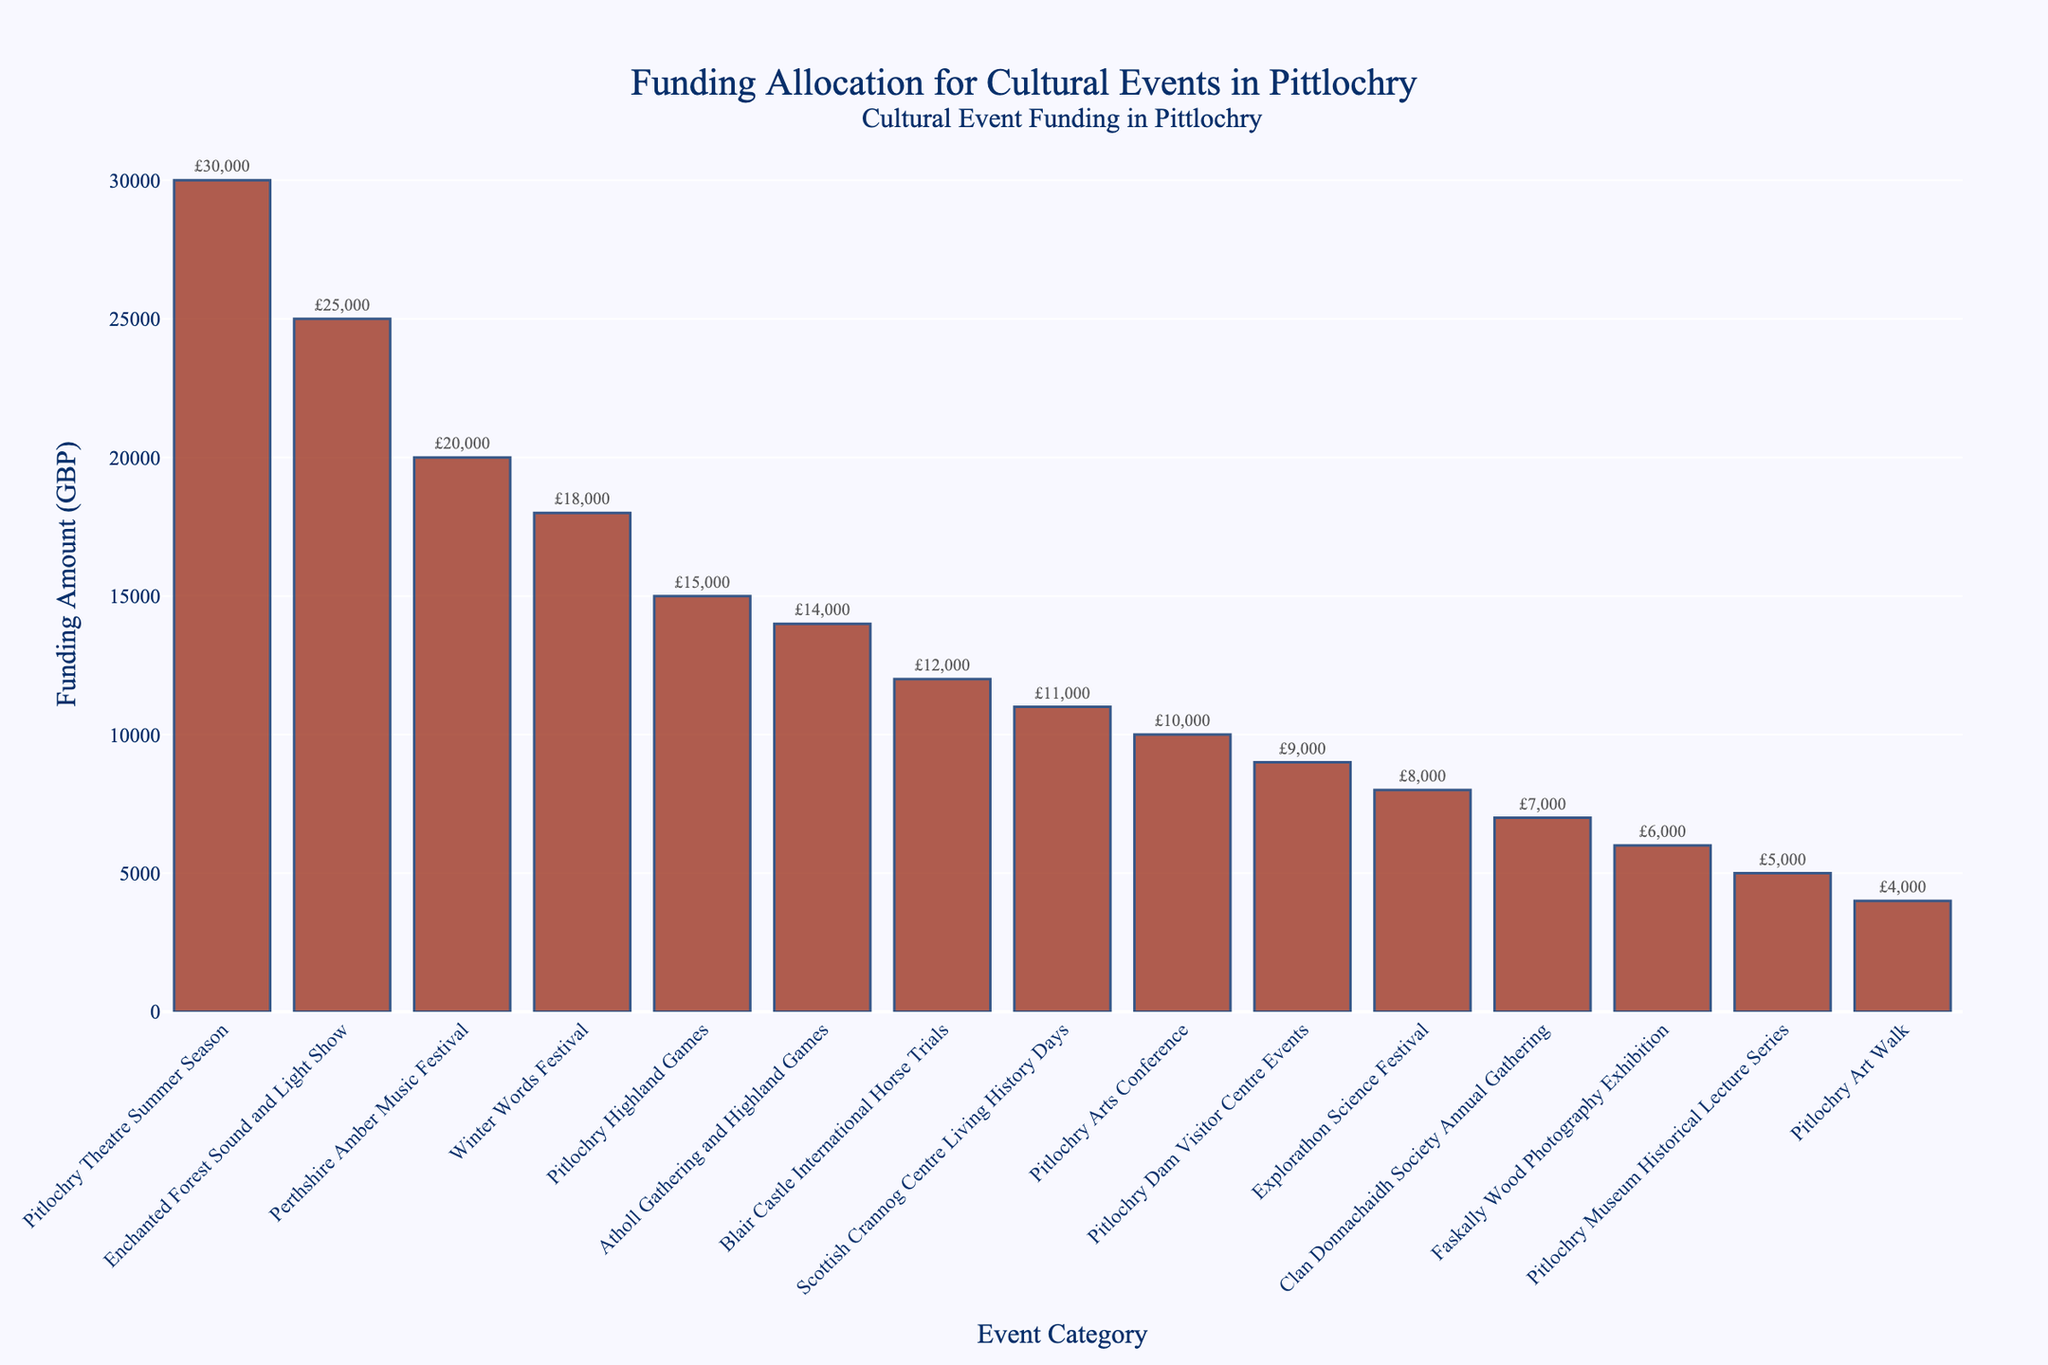Which event category received the highest amount of funding? The highest bar corresponds to the "Pitlochry Theatre Summer Season," which received the highest funding amount.
Answer: Pitlochry Theatre Summer Season How much more funding did the Enchanted Forest Sound and Light Show receive compared to the Pitlochry Highland Games? The funding for the Enchanted Forest Sound and Light Show is £25,000, while the funding for the Pitlochry Highland Games is £15,000. The difference between the two is £25,000 - £15,000 = £10,000.
Answer: £10,000 What is the total funding allocated for historical events (Pitlochry Highland Games, Atholl Gathering and Highland Games, Blair Castle International Horse Trials, Clan Donnachaidh Society Annual Gathering)? Adding the funding for historical events: £15,000 (Pitlochry Highland Games) + £14,000 (Atholl Gathering and Highland Games) + £12,000 (Blair Castle International Horse Trials) + £7,000 (Clan Donnachaidh Society Annual Gathering) = £48,000.
Answer: £48,000 Which event category received the least amount of funding, and what was the amount? The shortest bar corresponds to the "Pitlochry Art Walk," which received the least funding amount.
Answer: Pitlochry Art Walk; £4,000 Are there more events that received funding over £10,000 or under £10,000? Count the bars representing funding over £10,000 (7 events: Pitlochry Highland Games, Enchanted Forest Sound and Light Show, Pitlochry Theatre Summer Season, Blair Castle International Horse Trials, Atholl Gathering and Highland Games, Winter Words Festival, Perthshire Amber Music Festival) and under £10,000 (8 events: Explorathon Science Festival, Clan Donnachaidh Society Annual Gathering, Pitlochry Dam Visitor Centre Events, Scottish Crannog Centre Living History Days, Pitlochry Arts Conference, Pitlochry Museum Historical Lecture Series, Faskally Wood Photography Exhibition, Pitlochry Art Walk).
Answer: Under £10,000 What is the combined funding for the "Winter Words Festival" and "Perthshire Amber Music Festival"? Add the funding for the Winter Words Festival (£18,000) and the Perthshire Amber Music Festival (£20,000): £18,000 + £20,000 = £38,000.
Answer: £38,000 Which category of event received more funding: festivals or exhibitions (considering Faskally Wood Photography Exhibition and any other relevant exhibitions)? Festivals have higher funding: Pitlochry Theatre Summer Season (£30,000), Enchanted Forest (£25,000), Perthshire Amber (£20,000), Winter Words (£18,000), and others, outnumbering the Faskally Wood Photography Exhibition (£6,000) and related exhibitions.
Answer: Festivals What is the average funding amount for all listed cultural events? Sum the total funding and divide by the number of events: (£15,000 + £25,000 + £30,000 + £8,000 + £12,000 + £10,000 + £14,000 + £6,000 + £5,000 + £18,000 + £20,000 + £7,000 + £9,000 + £11,000 + £4,000) / 15 = £194,000 / 15 = £12,933.33.
Answer: £12,933.33 Which event categories received an equal amount of funding and what is that amount? The categories "Atholl Gathering and Highland Games" and "Blair Castle International Horse Trials" received equal funding of £12,000 each.
Answer: Atholl Gathering and Highland Games, Blair Castle International Horse Trials; £12,000 